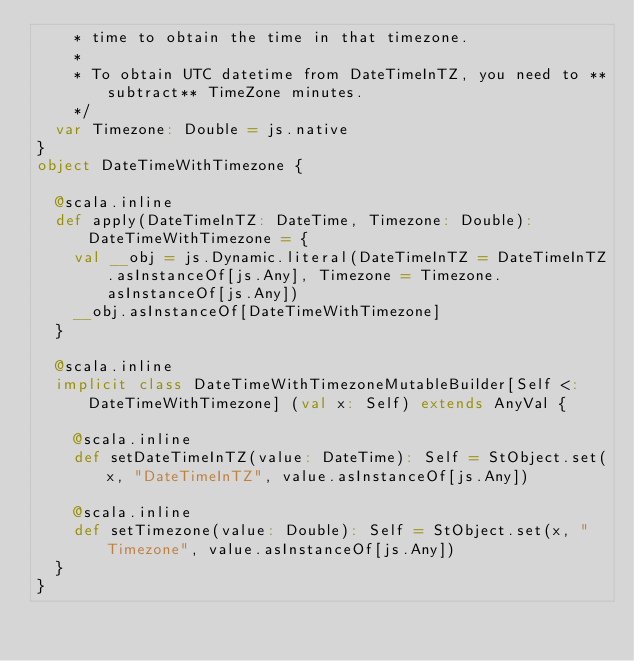<code> <loc_0><loc_0><loc_500><loc_500><_Scala_>    * time to obtain the time in that timezone.
    *
    * To obtain UTC datetime from DateTimeInTZ, you need to **subtract** TimeZone minutes.
    */
  var Timezone: Double = js.native
}
object DateTimeWithTimezone {
  
  @scala.inline
  def apply(DateTimeInTZ: DateTime, Timezone: Double): DateTimeWithTimezone = {
    val __obj = js.Dynamic.literal(DateTimeInTZ = DateTimeInTZ.asInstanceOf[js.Any], Timezone = Timezone.asInstanceOf[js.Any])
    __obj.asInstanceOf[DateTimeWithTimezone]
  }
  
  @scala.inline
  implicit class DateTimeWithTimezoneMutableBuilder[Self <: DateTimeWithTimezone] (val x: Self) extends AnyVal {
    
    @scala.inline
    def setDateTimeInTZ(value: DateTime): Self = StObject.set(x, "DateTimeInTZ", value.asInstanceOf[js.Any])
    
    @scala.inline
    def setTimezone(value: Double): Self = StObject.set(x, "Timezone", value.asInstanceOf[js.Any])
  }
}
</code> 